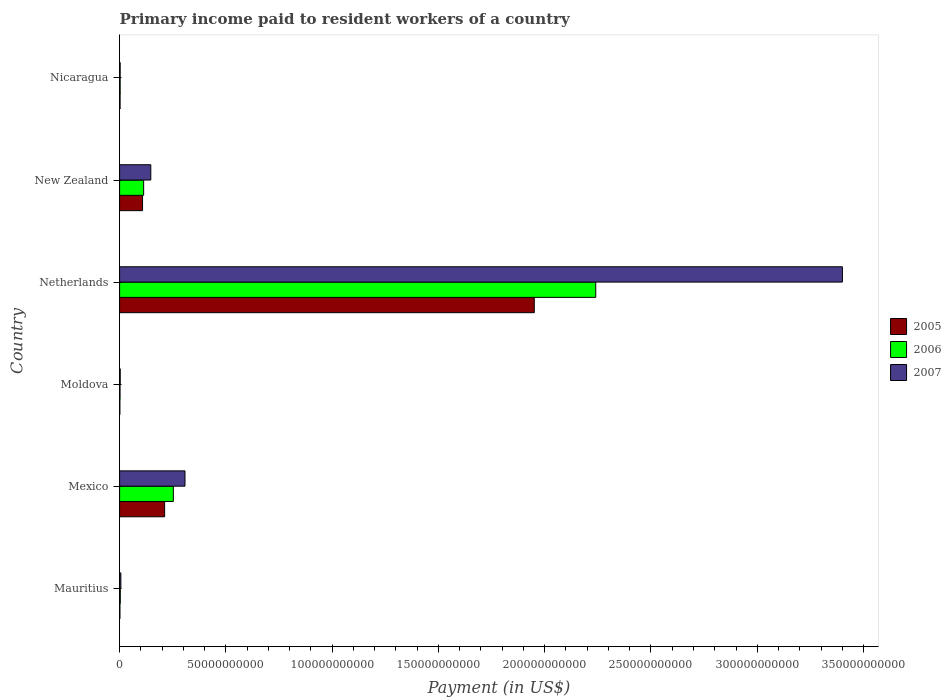How many different coloured bars are there?
Give a very brief answer. 3. Are the number of bars on each tick of the Y-axis equal?
Provide a short and direct response. Yes. How many bars are there on the 1st tick from the bottom?
Offer a terse response. 3. What is the label of the 2nd group of bars from the top?
Make the answer very short. New Zealand. What is the amount paid to workers in 2005 in New Zealand?
Keep it short and to the point. 1.08e+1. Across all countries, what is the maximum amount paid to workers in 2007?
Your answer should be very brief. 3.40e+11. Across all countries, what is the minimum amount paid to workers in 2006?
Ensure brevity in your answer.  2.03e+08. In which country was the amount paid to workers in 2007 minimum?
Your response must be concise. Nicaragua. What is the total amount paid to workers in 2005 in the graph?
Ensure brevity in your answer.  2.28e+11. What is the difference between the amount paid to workers in 2005 in Mexico and that in Nicaragua?
Offer a very short reply. 2.10e+1. What is the difference between the amount paid to workers in 2005 in Netherlands and the amount paid to workers in 2007 in Nicaragua?
Provide a short and direct response. 1.95e+11. What is the average amount paid to workers in 2006 per country?
Offer a terse response. 4.36e+1. What is the difference between the amount paid to workers in 2005 and amount paid to workers in 2007 in Mexico?
Provide a succinct answer. -9.58e+09. In how many countries, is the amount paid to workers in 2007 greater than 30000000000 US$?
Make the answer very short. 2. What is the ratio of the amount paid to workers in 2005 in Mexico to that in Netherlands?
Your answer should be very brief. 0.11. What is the difference between the highest and the second highest amount paid to workers in 2007?
Provide a short and direct response. 3.09e+11. What is the difference between the highest and the lowest amount paid to workers in 2005?
Your answer should be very brief. 1.95e+11. Is the sum of the amount paid to workers in 2005 in Mauritius and Mexico greater than the maximum amount paid to workers in 2006 across all countries?
Your response must be concise. No. How many bars are there?
Your answer should be compact. 18. How many countries are there in the graph?
Offer a terse response. 6. Are the values on the major ticks of X-axis written in scientific E-notation?
Your answer should be compact. No. Does the graph contain any zero values?
Ensure brevity in your answer.  No. Does the graph contain grids?
Your response must be concise. No. How many legend labels are there?
Make the answer very short. 3. What is the title of the graph?
Make the answer very short. Primary income paid to resident workers of a country. What is the label or title of the X-axis?
Provide a short and direct response. Payment (in US$). What is the label or title of the Y-axis?
Give a very brief answer. Country. What is the Payment (in US$) of 2005 in Mauritius?
Provide a succinct answer. 1.51e+08. What is the Payment (in US$) in 2006 in Mauritius?
Your response must be concise. 3.24e+08. What is the Payment (in US$) of 2007 in Mauritius?
Provide a short and direct response. 5.93e+08. What is the Payment (in US$) in 2005 in Mexico?
Offer a terse response. 2.12e+1. What is the Payment (in US$) of 2006 in Mexico?
Offer a very short reply. 2.53e+1. What is the Payment (in US$) of 2007 in Mexico?
Offer a terse response. 3.08e+1. What is the Payment (in US$) in 2005 in Moldova?
Offer a terse response. 1.28e+08. What is the Payment (in US$) of 2006 in Moldova?
Offer a terse response. 2.03e+08. What is the Payment (in US$) in 2007 in Moldova?
Make the answer very short. 2.94e+08. What is the Payment (in US$) in 2005 in Netherlands?
Your answer should be compact. 1.95e+11. What is the Payment (in US$) of 2006 in Netherlands?
Offer a very short reply. 2.24e+11. What is the Payment (in US$) of 2007 in Netherlands?
Provide a short and direct response. 3.40e+11. What is the Payment (in US$) in 2005 in New Zealand?
Make the answer very short. 1.08e+1. What is the Payment (in US$) in 2006 in New Zealand?
Provide a short and direct response. 1.13e+1. What is the Payment (in US$) of 2007 in New Zealand?
Keep it short and to the point. 1.47e+1. What is the Payment (in US$) of 2005 in Nicaragua?
Provide a succinct answer. 2.22e+08. What is the Payment (in US$) in 2006 in Nicaragua?
Your answer should be compact. 2.62e+08. What is the Payment (in US$) in 2007 in Nicaragua?
Provide a succinct answer. 2.61e+08. Across all countries, what is the maximum Payment (in US$) of 2005?
Give a very brief answer. 1.95e+11. Across all countries, what is the maximum Payment (in US$) in 2006?
Offer a terse response. 2.24e+11. Across all countries, what is the maximum Payment (in US$) of 2007?
Ensure brevity in your answer.  3.40e+11. Across all countries, what is the minimum Payment (in US$) of 2005?
Provide a short and direct response. 1.28e+08. Across all countries, what is the minimum Payment (in US$) of 2006?
Keep it short and to the point. 2.03e+08. Across all countries, what is the minimum Payment (in US$) in 2007?
Provide a succinct answer. 2.61e+08. What is the total Payment (in US$) of 2005 in the graph?
Your response must be concise. 2.28e+11. What is the total Payment (in US$) in 2006 in the graph?
Provide a short and direct response. 2.61e+11. What is the total Payment (in US$) in 2007 in the graph?
Your response must be concise. 3.87e+11. What is the difference between the Payment (in US$) in 2005 in Mauritius and that in Mexico?
Ensure brevity in your answer.  -2.10e+1. What is the difference between the Payment (in US$) of 2006 in Mauritius and that in Mexico?
Your response must be concise. -2.50e+1. What is the difference between the Payment (in US$) of 2007 in Mauritius and that in Mexico?
Offer a very short reply. -3.02e+1. What is the difference between the Payment (in US$) in 2005 in Mauritius and that in Moldova?
Offer a terse response. 2.30e+07. What is the difference between the Payment (in US$) of 2006 in Mauritius and that in Moldova?
Your response must be concise. 1.20e+08. What is the difference between the Payment (in US$) in 2007 in Mauritius and that in Moldova?
Provide a short and direct response. 3.00e+08. What is the difference between the Payment (in US$) in 2005 in Mauritius and that in Netherlands?
Give a very brief answer. -1.95e+11. What is the difference between the Payment (in US$) in 2006 in Mauritius and that in Netherlands?
Give a very brief answer. -2.24e+11. What is the difference between the Payment (in US$) in 2007 in Mauritius and that in Netherlands?
Your response must be concise. -3.39e+11. What is the difference between the Payment (in US$) of 2005 in Mauritius and that in New Zealand?
Offer a terse response. -1.06e+1. What is the difference between the Payment (in US$) of 2006 in Mauritius and that in New Zealand?
Provide a succinct answer. -1.10e+1. What is the difference between the Payment (in US$) in 2007 in Mauritius and that in New Zealand?
Offer a very short reply. -1.41e+1. What is the difference between the Payment (in US$) in 2005 in Mauritius and that in Nicaragua?
Provide a succinct answer. -7.07e+07. What is the difference between the Payment (in US$) in 2006 in Mauritius and that in Nicaragua?
Provide a succinct answer. 6.23e+07. What is the difference between the Payment (in US$) in 2007 in Mauritius and that in Nicaragua?
Provide a succinct answer. 3.32e+08. What is the difference between the Payment (in US$) of 2005 in Mexico and that in Moldova?
Your answer should be very brief. 2.11e+1. What is the difference between the Payment (in US$) of 2006 in Mexico and that in Moldova?
Give a very brief answer. 2.51e+1. What is the difference between the Payment (in US$) of 2007 in Mexico and that in Moldova?
Keep it short and to the point. 3.05e+1. What is the difference between the Payment (in US$) of 2005 in Mexico and that in Netherlands?
Ensure brevity in your answer.  -1.74e+11. What is the difference between the Payment (in US$) of 2006 in Mexico and that in Netherlands?
Provide a succinct answer. -1.99e+11. What is the difference between the Payment (in US$) of 2007 in Mexico and that in Netherlands?
Make the answer very short. -3.09e+11. What is the difference between the Payment (in US$) in 2005 in Mexico and that in New Zealand?
Offer a very short reply. 1.04e+1. What is the difference between the Payment (in US$) of 2006 in Mexico and that in New Zealand?
Your answer should be very brief. 1.40e+1. What is the difference between the Payment (in US$) of 2007 in Mexico and that in New Zealand?
Provide a short and direct response. 1.61e+1. What is the difference between the Payment (in US$) of 2005 in Mexico and that in Nicaragua?
Make the answer very short. 2.10e+1. What is the difference between the Payment (in US$) of 2006 in Mexico and that in Nicaragua?
Your answer should be compact. 2.50e+1. What is the difference between the Payment (in US$) in 2007 in Mexico and that in Nicaragua?
Ensure brevity in your answer.  3.05e+1. What is the difference between the Payment (in US$) of 2005 in Moldova and that in Netherlands?
Your answer should be compact. -1.95e+11. What is the difference between the Payment (in US$) in 2006 in Moldova and that in Netherlands?
Provide a succinct answer. -2.24e+11. What is the difference between the Payment (in US$) of 2007 in Moldova and that in Netherlands?
Provide a short and direct response. -3.40e+11. What is the difference between the Payment (in US$) in 2005 in Moldova and that in New Zealand?
Offer a terse response. -1.07e+1. What is the difference between the Payment (in US$) of 2006 in Moldova and that in New Zealand?
Your answer should be compact. -1.11e+1. What is the difference between the Payment (in US$) of 2007 in Moldova and that in New Zealand?
Your answer should be compact. -1.44e+1. What is the difference between the Payment (in US$) in 2005 in Moldova and that in Nicaragua?
Offer a terse response. -9.36e+07. What is the difference between the Payment (in US$) in 2006 in Moldova and that in Nicaragua?
Keep it short and to the point. -5.81e+07. What is the difference between the Payment (in US$) in 2007 in Moldova and that in Nicaragua?
Your response must be concise. 3.23e+07. What is the difference between the Payment (in US$) of 2005 in Netherlands and that in New Zealand?
Your answer should be compact. 1.84e+11. What is the difference between the Payment (in US$) in 2006 in Netherlands and that in New Zealand?
Your response must be concise. 2.13e+11. What is the difference between the Payment (in US$) in 2007 in Netherlands and that in New Zealand?
Offer a very short reply. 3.25e+11. What is the difference between the Payment (in US$) of 2005 in Netherlands and that in Nicaragua?
Offer a very short reply. 1.95e+11. What is the difference between the Payment (in US$) in 2006 in Netherlands and that in Nicaragua?
Provide a succinct answer. 2.24e+11. What is the difference between the Payment (in US$) in 2007 in Netherlands and that in Nicaragua?
Provide a succinct answer. 3.40e+11. What is the difference between the Payment (in US$) in 2005 in New Zealand and that in Nicaragua?
Your answer should be very brief. 1.06e+1. What is the difference between the Payment (in US$) in 2006 in New Zealand and that in Nicaragua?
Provide a short and direct response. 1.11e+1. What is the difference between the Payment (in US$) in 2007 in New Zealand and that in Nicaragua?
Give a very brief answer. 1.44e+1. What is the difference between the Payment (in US$) of 2005 in Mauritius and the Payment (in US$) of 2006 in Mexico?
Your response must be concise. -2.51e+1. What is the difference between the Payment (in US$) in 2005 in Mauritius and the Payment (in US$) in 2007 in Mexico?
Keep it short and to the point. -3.06e+1. What is the difference between the Payment (in US$) in 2006 in Mauritius and the Payment (in US$) in 2007 in Mexico?
Your response must be concise. -3.04e+1. What is the difference between the Payment (in US$) in 2005 in Mauritius and the Payment (in US$) in 2006 in Moldova?
Make the answer very short. -5.20e+07. What is the difference between the Payment (in US$) of 2005 in Mauritius and the Payment (in US$) of 2007 in Moldova?
Offer a terse response. -1.42e+08. What is the difference between the Payment (in US$) in 2006 in Mauritius and the Payment (in US$) in 2007 in Moldova?
Your answer should be compact. 3.02e+07. What is the difference between the Payment (in US$) in 2005 in Mauritius and the Payment (in US$) in 2006 in Netherlands?
Make the answer very short. -2.24e+11. What is the difference between the Payment (in US$) of 2005 in Mauritius and the Payment (in US$) of 2007 in Netherlands?
Ensure brevity in your answer.  -3.40e+11. What is the difference between the Payment (in US$) of 2006 in Mauritius and the Payment (in US$) of 2007 in Netherlands?
Offer a terse response. -3.40e+11. What is the difference between the Payment (in US$) in 2005 in Mauritius and the Payment (in US$) in 2006 in New Zealand?
Keep it short and to the point. -1.12e+1. What is the difference between the Payment (in US$) in 2005 in Mauritius and the Payment (in US$) in 2007 in New Zealand?
Ensure brevity in your answer.  -1.45e+1. What is the difference between the Payment (in US$) in 2006 in Mauritius and the Payment (in US$) in 2007 in New Zealand?
Your answer should be very brief. -1.44e+1. What is the difference between the Payment (in US$) in 2005 in Mauritius and the Payment (in US$) in 2006 in Nicaragua?
Your answer should be very brief. -1.10e+08. What is the difference between the Payment (in US$) in 2005 in Mauritius and the Payment (in US$) in 2007 in Nicaragua?
Your answer should be very brief. -1.10e+08. What is the difference between the Payment (in US$) in 2006 in Mauritius and the Payment (in US$) in 2007 in Nicaragua?
Make the answer very short. 6.24e+07. What is the difference between the Payment (in US$) of 2005 in Mexico and the Payment (in US$) of 2006 in Moldova?
Give a very brief answer. 2.10e+1. What is the difference between the Payment (in US$) of 2005 in Mexico and the Payment (in US$) of 2007 in Moldova?
Offer a terse response. 2.09e+1. What is the difference between the Payment (in US$) of 2006 in Mexico and the Payment (in US$) of 2007 in Moldova?
Keep it short and to the point. 2.50e+1. What is the difference between the Payment (in US$) in 2005 in Mexico and the Payment (in US$) in 2006 in Netherlands?
Give a very brief answer. -2.03e+11. What is the difference between the Payment (in US$) in 2005 in Mexico and the Payment (in US$) in 2007 in Netherlands?
Provide a succinct answer. -3.19e+11. What is the difference between the Payment (in US$) of 2006 in Mexico and the Payment (in US$) of 2007 in Netherlands?
Ensure brevity in your answer.  -3.15e+11. What is the difference between the Payment (in US$) in 2005 in Mexico and the Payment (in US$) in 2006 in New Zealand?
Your answer should be very brief. 9.87e+09. What is the difference between the Payment (in US$) of 2005 in Mexico and the Payment (in US$) of 2007 in New Zealand?
Provide a short and direct response. 6.50e+09. What is the difference between the Payment (in US$) of 2006 in Mexico and the Payment (in US$) of 2007 in New Zealand?
Make the answer very short. 1.06e+1. What is the difference between the Payment (in US$) in 2005 in Mexico and the Payment (in US$) in 2006 in Nicaragua?
Make the answer very short. 2.09e+1. What is the difference between the Payment (in US$) of 2005 in Mexico and the Payment (in US$) of 2007 in Nicaragua?
Offer a very short reply. 2.09e+1. What is the difference between the Payment (in US$) in 2006 in Mexico and the Payment (in US$) in 2007 in Nicaragua?
Give a very brief answer. 2.50e+1. What is the difference between the Payment (in US$) of 2005 in Moldova and the Payment (in US$) of 2006 in Netherlands?
Keep it short and to the point. -2.24e+11. What is the difference between the Payment (in US$) of 2005 in Moldova and the Payment (in US$) of 2007 in Netherlands?
Your answer should be compact. -3.40e+11. What is the difference between the Payment (in US$) of 2006 in Moldova and the Payment (in US$) of 2007 in Netherlands?
Keep it short and to the point. -3.40e+11. What is the difference between the Payment (in US$) of 2005 in Moldova and the Payment (in US$) of 2006 in New Zealand?
Give a very brief answer. -1.12e+1. What is the difference between the Payment (in US$) of 2005 in Moldova and the Payment (in US$) of 2007 in New Zealand?
Provide a succinct answer. -1.46e+1. What is the difference between the Payment (in US$) of 2006 in Moldova and the Payment (in US$) of 2007 in New Zealand?
Your answer should be very brief. -1.45e+1. What is the difference between the Payment (in US$) of 2005 in Moldova and the Payment (in US$) of 2006 in Nicaragua?
Give a very brief answer. -1.33e+08. What is the difference between the Payment (in US$) of 2005 in Moldova and the Payment (in US$) of 2007 in Nicaragua?
Offer a terse response. -1.33e+08. What is the difference between the Payment (in US$) in 2006 in Moldova and the Payment (in US$) in 2007 in Nicaragua?
Your answer should be very brief. -5.80e+07. What is the difference between the Payment (in US$) of 2005 in Netherlands and the Payment (in US$) of 2006 in New Zealand?
Your response must be concise. 1.84e+11. What is the difference between the Payment (in US$) in 2005 in Netherlands and the Payment (in US$) in 2007 in New Zealand?
Your answer should be compact. 1.80e+11. What is the difference between the Payment (in US$) of 2006 in Netherlands and the Payment (in US$) of 2007 in New Zealand?
Provide a short and direct response. 2.09e+11. What is the difference between the Payment (in US$) of 2005 in Netherlands and the Payment (in US$) of 2006 in Nicaragua?
Give a very brief answer. 1.95e+11. What is the difference between the Payment (in US$) in 2005 in Netherlands and the Payment (in US$) in 2007 in Nicaragua?
Provide a short and direct response. 1.95e+11. What is the difference between the Payment (in US$) in 2006 in Netherlands and the Payment (in US$) in 2007 in Nicaragua?
Provide a succinct answer. 2.24e+11. What is the difference between the Payment (in US$) of 2005 in New Zealand and the Payment (in US$) of 2006 in Nicaragua?
Offer a very short reply. 1.05e+1. What is the difference between the Payment (in US$) of 2005 in New Zealand and the Payment (in US$) of 2007 in Nicaragua?
Your response must be concise. 1.05e+1. What is the difference between the Payment (in US$) in 2006 in New Zealand and the Payment (in US$) in 2007 in Nicaragua?
Ensure brevity in your answer.  1.11e+1. What is the average Payment (in US$) in 2005 per country?
Offer a terse response. 3.79e+1. What is the average Payment (in US$) of 2006 per country?
Your response must be concise. 4.36e+1. What is the average Payment (in US$) of 2007 per country?
Provide a short and direct response. 6.44e+1. What is the difference between the Payment (in US$) in 2005 and Payment (in US$) in 2006 in Mauritius?
Offer a very short reply. -1.72e+08. What is the difference between the Payment (in US$) in 2005 and Payment (in US$) in 2007 in Mauritius?
Offer a terse response. -4.42e+08. What is the difference between the Payment (in US$) of 2006 and Payment (in US$) of 2007 in Mauritius?
Provide a succinct answer. -2.69e+08. What is the difference between the Payment (in US$) in 2005 and Payment (in US$) in 2006 in Mexico?
Give a very brief answer. -4.10e+09. What is the difference between the Payment (in US$) of 2005 and Payment (in US$) of 2007 in Mexico?
Offer a terse response. -9.58e+09. What is the difference between the Payment (in US$) in 2006 and Payment (in US$) in 2007 in Mexico?
Your answer should be very brief. -5.48e+09. What is the difference between the Payment (in US$) of 2005 and Payment (in US$) of 2006 in Moldova?
Ensure brevity in your answer.  -7.50e+07. What is the difference between the Payment (in US$) of 2005 and Payment (in US$) of 2007 in Moldova?
Provide a succinct answer. -1.65e+08. What is the difference between the Payment (in US$) of 2006 and Payment (in US$) of 2007 in Moldova?
Keep it short and to the point. -9.03e+07. What is the difference between the Payment (in US$) of 2005 and Payment (in US$) of 2006 in Netherlands?
Provide a succinct answer. -2.89e+1. What is the difference between the Payment (in US$) of 2005 and Payment (in US$) of 2007 in Netherlands?
Ensure brevity in your answer.  -1.45e+11. What is the difference between the Payment (in US$) in 2006 and Payment (in US$) in 2007 in Netherlands?
Provide a short and direct response. -1.16e+11. What is the difference between the Payment (in US$) in 2005 and Payment (in US$) in 2006 in New Zealand?
Your answer should be very brief. -5.20e+08. What is the difference between the Payment (in US$) in 2005 and Payment (in US$) in 2007 in New Zealand?
Keep it short and to the point. -3.88e+09. What is the difference between the Payment (in US$) of 2006 and Payment (in US$) of 2007 in New Zealand?
Ensure brevity in your answer.  -3.36e+09. What is the difference between the Payment (in US$) in 2005 and Payment (in US$) in 2006 in Nicaragua?
Make the answer very short. -3.95e+07. What is the difference between the Payment (in US$) of 2005 and Payment (in US$) of 2007 in Nicaragua?
Your response must be concise. -3.94e+07. What is the difference between the Payment (in US$) of 2006 and Payment (in US$) of 2007 in Nicaragua?
Provide a succinct answer. 1.00e+05. What is the ratio of the Payment (in US$) in 2005 in Mauritius to that in Mexico?
Your answer should be very brief. 0.01. What is the ratio of the Payment (in US$) in 2006 in Mauritius to that in Mexico?
Offer a very short reply. 0.01. What is the ratio of the Payment (in US$) in 2007 in Mauritius to that in Mexico?
Offer a very short reply. 0.02. What is the ratio of the Payment (in US$) of 2005 in Mauritius to that in Moldova?
Your response must be concise. 1.18. What is the ratio of the Payment (in US$) in 2006 in Mauritius to that in Moldova?
Make the answer very short. 1.59. What is the ratio of the Payment (in US$) in 2007 in Mauritius to that in Moldova?
Your answer should be very brief. 2.02. What is the ratio of the Payment (in US$) in 2005 in Mauritius to that in Netherlands?
Your response must be concise. 0. What is the ratio of the Payment (in US$) of 2006 in Mauritius to that in Netherlands?
Make the answer very short. 0. What is the ratio of the Payment (in US$) of 2007 in Mauritius to that in Netherlands?
Your answer should be very brief. 0. What is the ratio of the Payment (in US$) of 2005 in Mauritius to that in New Zealand?
Your response must be concise. 0.01. What is the ratio of the Payment (in US$) in 2006 in Mauritius to that in New Zealand?
Offer a very short reply. 0.03. What is the ratio of the Payment (in US$) of 2007 in Mauritius to that in New Zealand?
Provide a succinct answer. 0.04. What is the ratio of the Payment (in US$) of 2005 in Mauritius to that in Nicaragua?
Provide a short and direct response. 0.68. What is the ratio of the Payment (in US$) in 2006 in Mauritius to that in Nicaragua?
Your answer should be very brief. 1.24. What is the ratio of the Payment (in US$) in 2007 in Mauritius to that in Nicaragua?
Your response must be concise. 2.27. What is the ratio of the Payment (in US$) of 2005 in Mexico to that in Moldova?
Provide a short and direct response. 164.99. What is the ratio of the Payment (in US$) in 2006 in Mexico to that in Moldova?
Make the answer very short. 124.33. What is the ratio of the Payment (in US$) of 2007 in Mexico to that in Moldova?
Provide a short and direct response. 104.75. What is the ratio of the Payment (in US$) of 2005 in Mexico to that in Netherlands?
Offer a very short reply. 0.11. What is the ratio of the Payment (in US$) in 2006 in Mexico to that in Netherlands?
Make the answer very short. 0.11. What is the ratio of the Payment (in US$) of 2007 in Mexico to that in Netherlands?
Your answer should be very brief. 0.09. What is the ratio of the Payment (in US$) of 2005 in Mexico to that in New Zealand?
Your answer should be very brief. 1.96. What is the ratio of the Payment (in US$) in 2006 in Mexico to that in New Zealand?
Keep it short and to the point. 2.23. What is the ratio of the Payment (in US$) in 2007 in Mexico to that in New Zealand?
Your answer should be very brief. 2.1. What is the ratio of the Payment (in US$) of 2005 in Mexico to that in Nicaragua?
Provide a short and direct response. 95.41. What is the ratio of the Payment (in US$) in 2006 in Mexico to that in Nicaragua?
Your answer should be very brief. 96.69. What is the ratio of the Payment (in US$) in 2007 in Mexico to that in Nicaragua?
Offer a very short reply. 117.68. What is the ratio of the Payment (in US$) in 2005 in Moldova to that in Netherlands?
Offer a very short reply. 0. What is the ratio of the Payment (in US$) in 2006 in Moldova to that in Netherlands?
Offer a very short reply. 0. What is the ratio of the Payment (in US$) in 2007 in Moldova to that in Netherlands?
Your answer should be very brief. 0. What is the ratio of the Payment (in US$) in 2005 in Moldova to that in New Zealand?
Your answer should be very brief. 0.01. What is the ratio of the Payment (in US$) in 2006 in Moldova to that in New Zealand?
Your answer should be compact. 0.02. What is the ratio of the Payment (in US$) in 2007 in Moldova to that in New Zealand?
Ensure brevity in your answer.  0.02. What is the ratio of the Payment (in US$) in 2005 in Moldova to that in Nicaragua?
Your answer should be compact. 0.58. What is the ratio of the Payment (in US$) in 2006 in Moldova to that in Nicaragua?
Give a very brief answer. 0.78. What is the ratio of the Payment (in US$) of 2007 in Moldova to that in Nicaragua?
Ensure brevity in your answer.  1.12. What is the ratio of the Payment (in US$) in 2005 in Netherlands to that in New Zealand?
Your answer should be compact. 18.07. What is the ratio of the Payment (in US$) of 2006 in Netherlands to that in New Zealand?
Give a very brief answer. 19.8. What is the ratio of the Payment (in US$) of 2007 in Netherlands to that in New Zealand?
Keep it short and to the point. 23.17. What is the ratio of the Payment (in US$) of 2005 in Netherlands to that in Nicaragua?
Offer a very short reply. 878.79. What is the ratio of the Payment (in US$) in 2006 in Netherlands to that in Nicaragua?
Provide a succinct answer. 856.65. What is the ratio of the Payment (in US$) in 2007 in Netherlands to that in Nicaragua?
Give a very brief answer. 1300.93. What is the ratio of the Payment (in US$) in 2005 in New Zealand to that in Nicaragua?
Give a very brief answer. 48.63. What is the ratio of the Payment (in US$) of 2006 in New Zealand to that in Nicaragua?
Make the answer very short. 43.27. What is the ratio of the Payment (in US$) in 2007 in New Zealand to that in Nicaragua?
Ensure brevity in your answer.  56.16. What is the difference between the highest and the second highest Payment (in US$) in 2005?
Give a very brief answer. 1.74e+11. What is the difference between the highest and the second highest Payment (in US$) of 2006?
Offer a very short reply. 1.99e+11. What is the difference between the highest and the second highest Payment (in US$) in 2007?
Give a very brief answer. 3.09e+11. What is the difference between the highest and the lowest Payment (in US$) in 2005?
Provide a succinct answer. 1.95e+11. What is the difference between the highest and the lowest Payment (in US$) in 2006?
Your answer should be compact. 2.24e+11. What is the difference between the highest and the lowest Payment (in US$) in 2007?
Make the answer very short. 3.40e+11. 